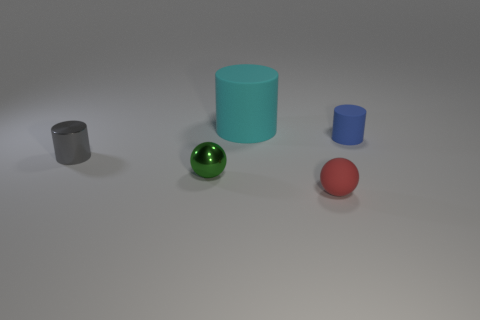Add 4 tiny green matte blocks. How many objects exist? 9 Subtract all spheres. How many objects are left? 3 Subtract all blue shiny objects. Subtract all small blue cylinders. How many objects are left? 4 Add 5 big cyan rubber things. How many big cyan rubber things are left? 6 Add 4 tiny red spheres. How many tiny red spheres exist? 5 Subtract 0 yellow cylinders. How many objects are left? 5 